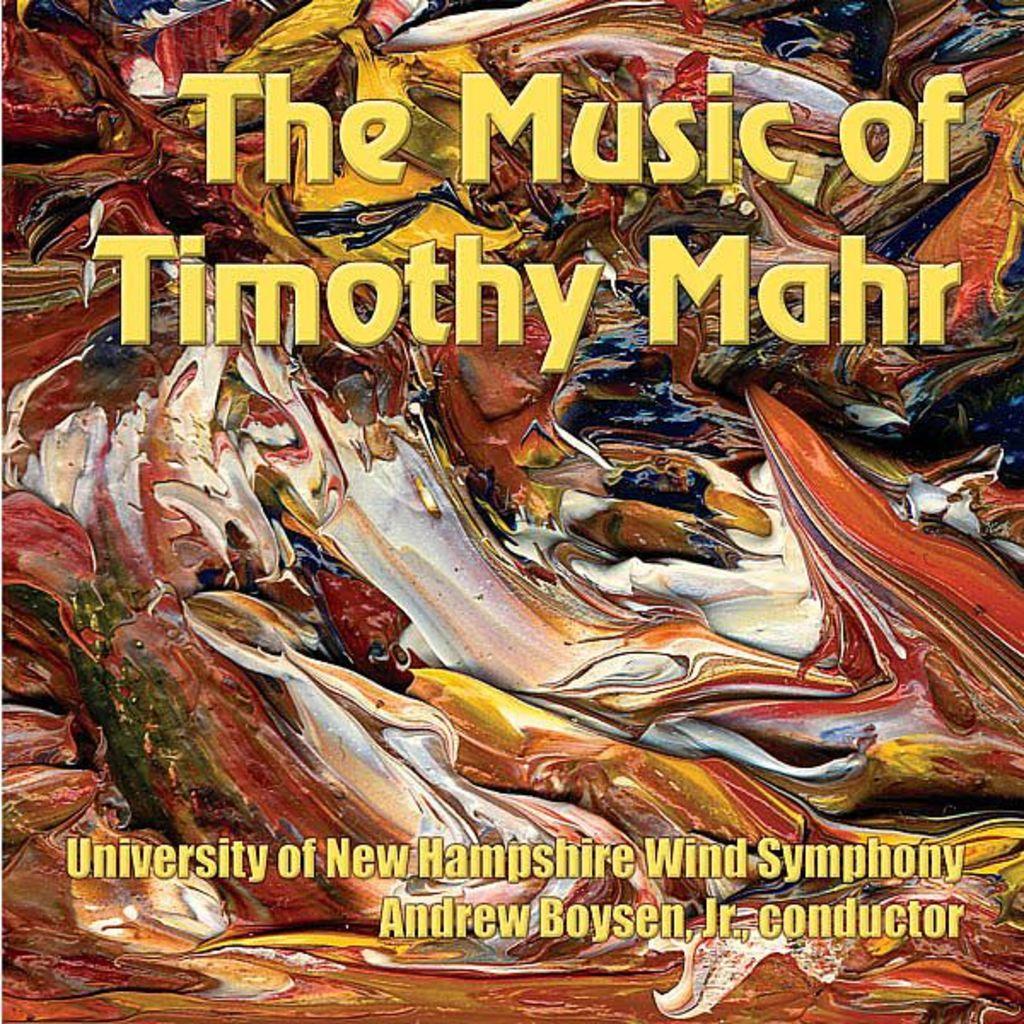The music of whom?
Your answer should be compact. Timothy mahr. What university is the wind symphony from?
Ensure brevity in your answer.  University of new hampshire. 